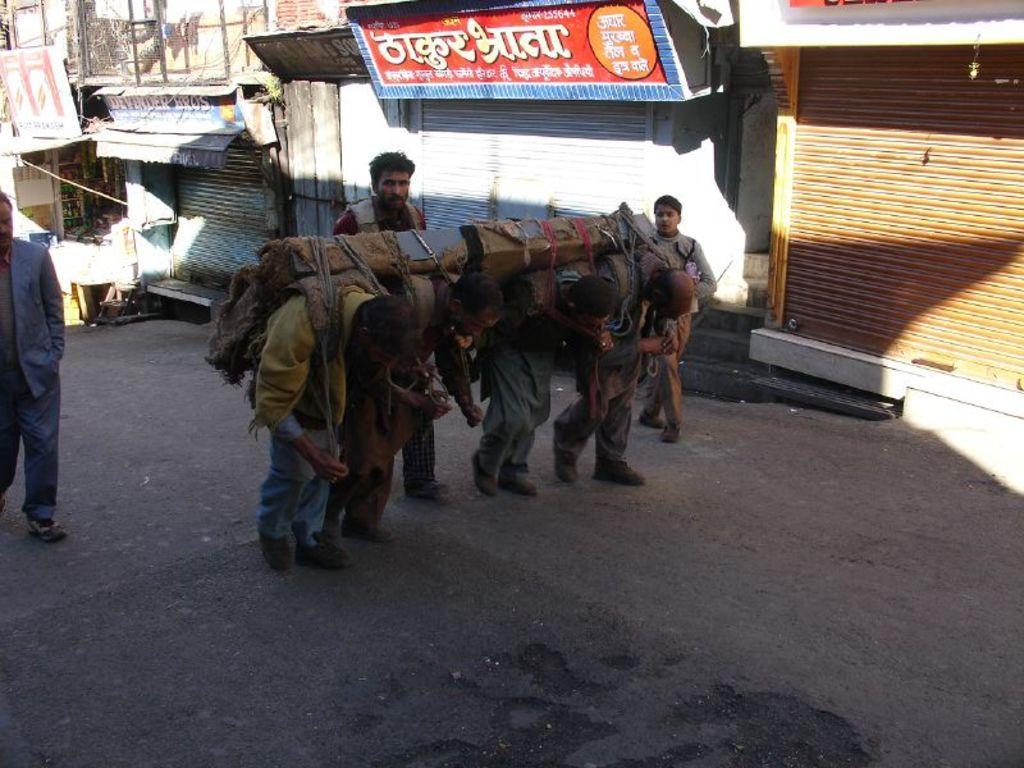Describe this image in one or two sentences. In this image we can see little people carrying iron rods on their shoulder. And we can see three people behind them. And we can see the road. And we can see board some text written on it. And we can see some shelters. 